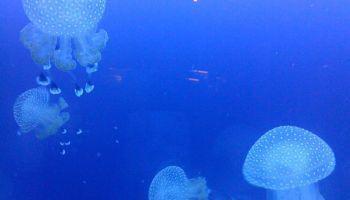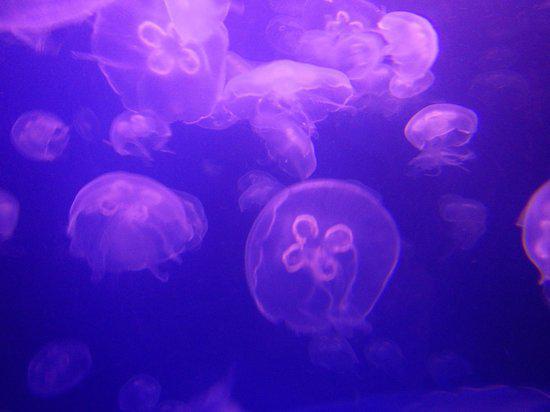The first image is the image on the left, the second image is the image on the right. For the images shown, is this caption "There area at least 10 jellyfish in the water and at least two with a clover looking inside facing forward lite in pink and blue." true? Answer yes or no. Yes. 